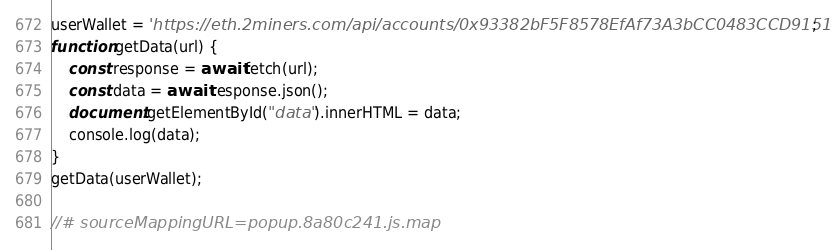<code> <loc_0><loc_0><loc_500><loc_500><_JavaScript_>userWallet = 'https://eth.2miners.com/api/accounts/0x93382bF5F8578EfAf73A3bCC0483CCD9151dc7Cb';
function getData(url) {
    const response = await fetch(url);
    const data = await response.json();
    document.getElementById("data").innerHTML = data;
    console.log(data);
}
getData(userWallet);

//# sourceMappingURL=popup.8a80c241.js.map
</code> 